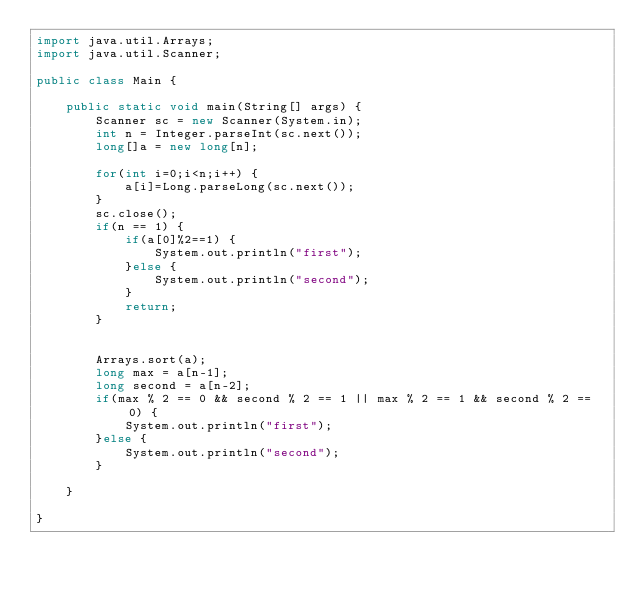<code> <loc_0><loc_0><loc_500><loc_500><_Java_>import java.util.Arrays;
import java.util.Scanner;

public class Main {

	public static void main(String[] args) {
		Scanner sc = new Scanner(System.in);
		int n = Integer.parseInt(sc.next());
		long[]a = new long[n];

		for(int i=0;i<n;i++) {
			a[i]=Long.parseLong(sc.next());
		}
		sc.close();
		if(n == 1) {
			if(a[0]%2==1) {
				System.out.println("first");
			}else {
				System.out.println("second");
			}
			return;
		}


		Arrays.sort(a);
		long max = a[n-1];
		long second = a[n-2];
		if(max % 2 == 0 && second % 2 == 1 || max % 2 == 1 && second % 2 == 0) {
			System.out.println("first");
		}else {
			System.out.println("second");
		}

	}

}
</code> 